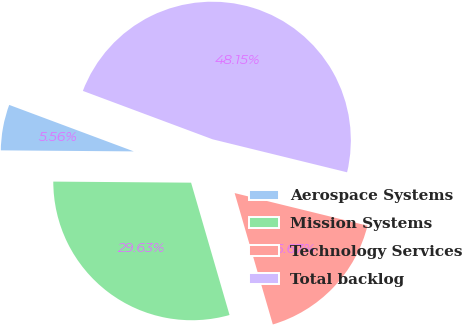Convert chart to OTSL. <chart><loc_0><loc_0><loc_500><loc_500><pie_chart><fcel>Aerospace Systems<fcel>Mission Systems<fcel>Technology Services<fcel>Total backlog<nl><fcel>5.56%<fcel>29.63%<fcel>16.67%<fcel>48.15%<nl></chart> 